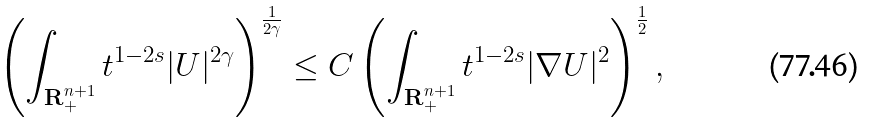<formula> <loc_0><loc_0><loc_500><loc_500>\left ( \int _ { \mathbf R ^ { n + 1 } _ { + } } t ^ { 1 - 2 s } | U | ^ { 2 \gamma } \right ) ^ { \frac { 1 } { 2 \gamma } } \leq C \left ( \int _ { \mathbf R ^ { n + 1 } _ { + } } t ^ { 1 - 2 s } | \nabla U | ^ { 2 } \right ) ^ { \frac { 1 } { 2 } } ,</formula> 